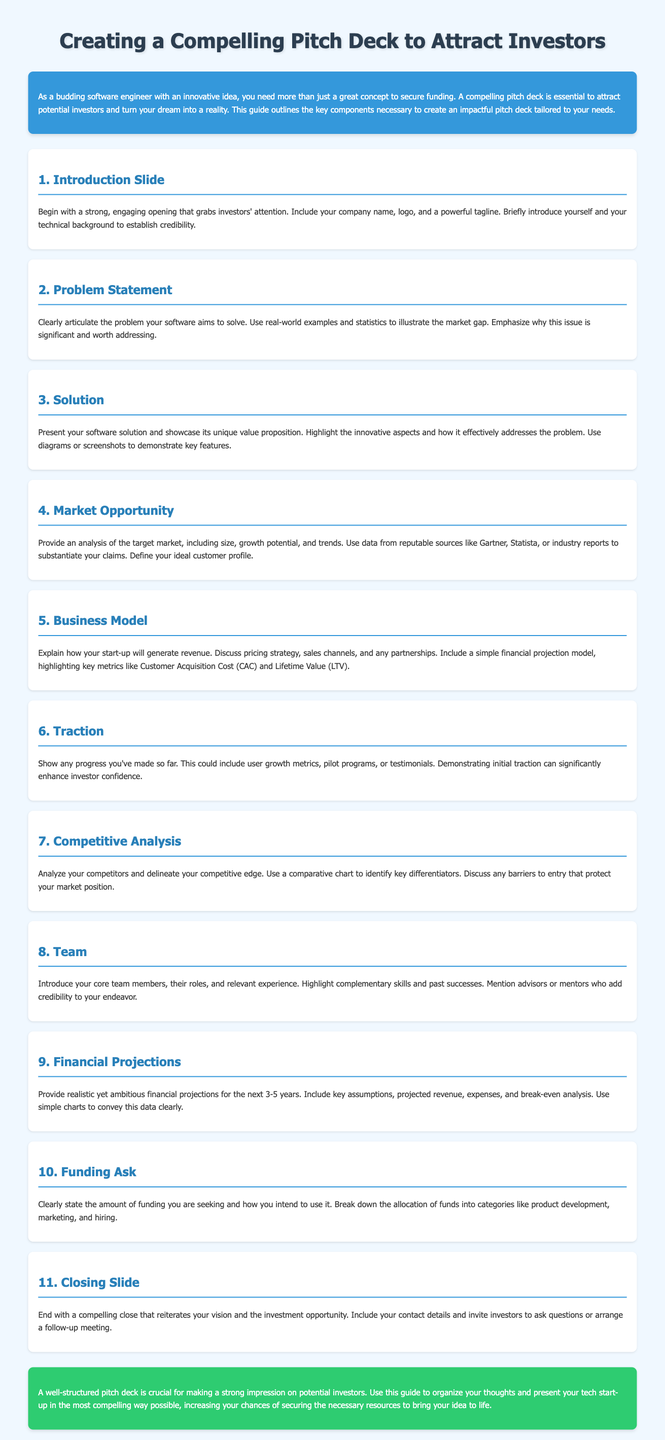What is the first slide in the pitch deck? The first slide is typically the Introduction Slide, which captures attention with the company name and logo.
Answer: Introduction Slide What should you include in the Problem Statement section? This section should clearly articulate the issue your software addresses, using examples and statistics.
Answer: Real-world examples and statistics What is the purpose of the Solution section? The Solution section presents the software and its unique value proposition, highlighting innovative aspects.
Answer: Showcase unique value proposition Which market research sources are suggested in the Market Opportunity section? Recommended sources for market data include Gartner, Statista, or industry reports.
Answer: Gartner, Statista, or industry reports What does the Funding Ask section outline? This section specifies the funding amount sought and how it will be allocated across categories.
Answer: Amount of funding sought Describe the focus of the Traction section. The Traction section should show any progress made, including user growth metrics or pilot programs.
Answer: User growth metrics or pilot programs In which slide do you introduce your core team members? Team members are introduced in the Team section of the pitch deck.
Answer: Team section What is emphasized in the Competitive Analysis section? The Competitive Analysis section emphasizes your competitive edge and any barriers to entry.
Answer: Competitive edge and barriers to entry How long should financial projections cover according to the guide? Financial projections should realistically cover the next 3-5 years.
Answer: 3-5 years 